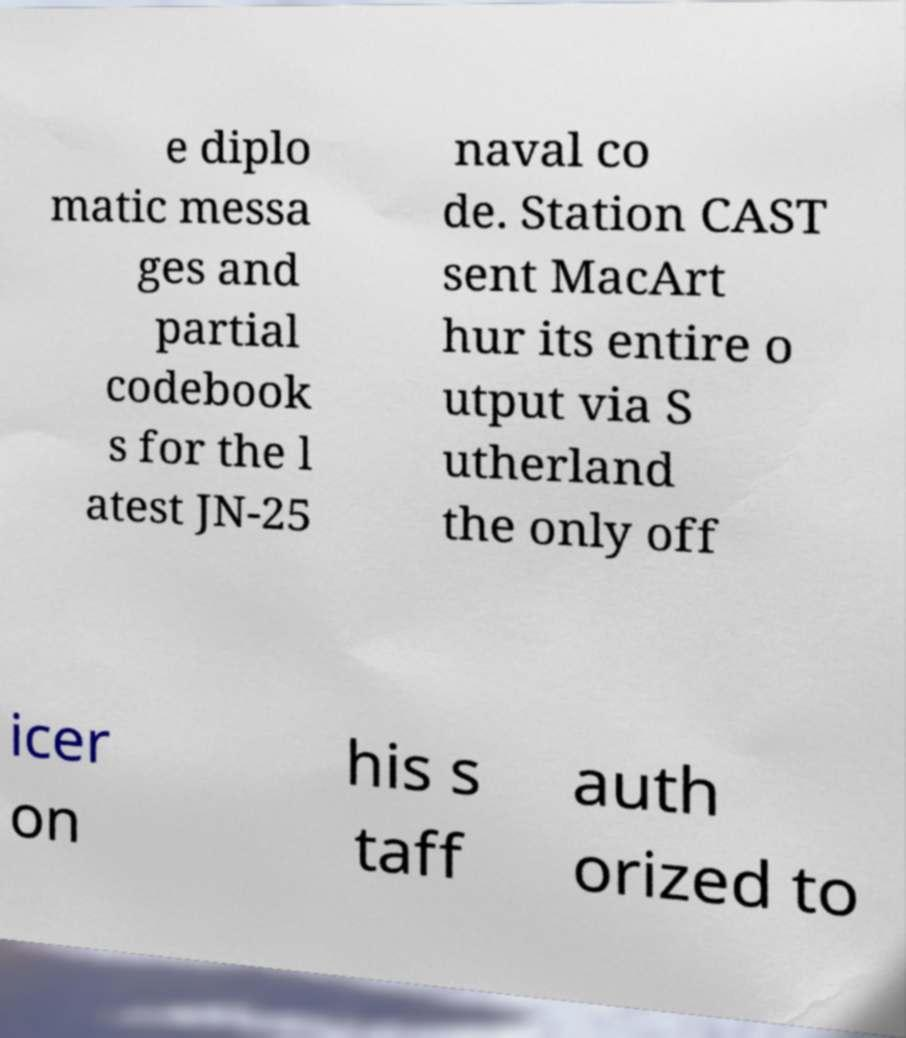Please identify and transcribe the text found in this image. e diplo matic messa ges and partial codebook s for the l atest JN-25 naval co de. Station CAST sent MacArt hur its entire o utput via S utherland the only off icer on his s taff auth orized to 